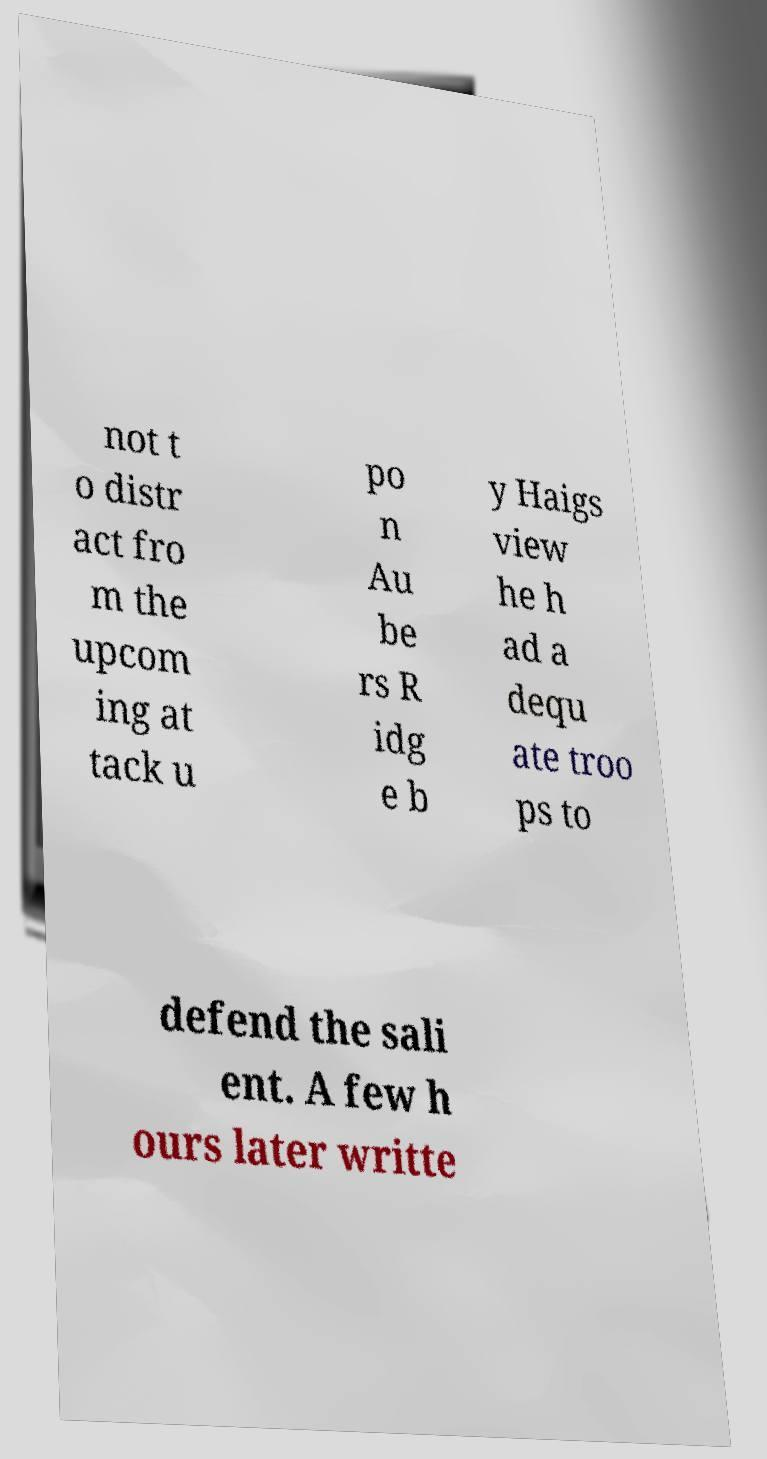For documentation purposes, I need the text within this image transcribed. Could you provide that? not t o distr act fro m the upcom ing at tack u po n Au be rs R idg e b y Haigs view he h ad a dequ ate troo ps to defend the sali ent. A few h ours later writte 